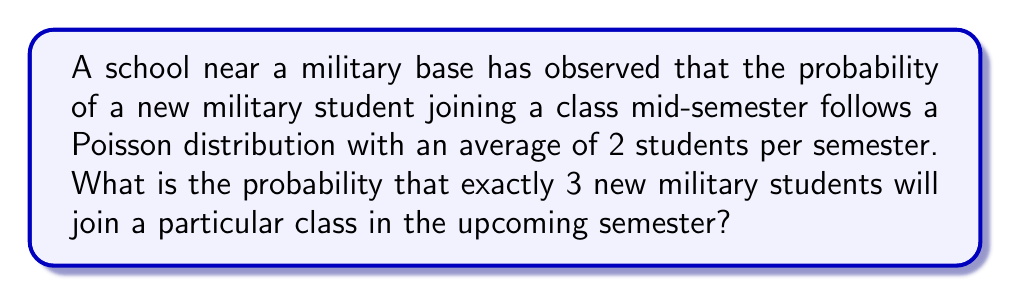What is the answer to this math problem? To solve this problem, we'll use the Poisson probability mass function:

$$P(X = k) = \frac{e^{-\lambda} \lambda^k}{k!}$$

Where:
$\lambda$ is the average rate of occurrence
$k$ is the number of occurrences we're interested in
$e$ is Euler's number (approximately 2.71828)

Given:
$\lambda = 2$ (average of 2 students per semester)
$k = 3$ (we want exactly 3 new students)

Step 1: Plug the values into the formula:
$$P(X = 3) = \frac{e^{-2} 2^3}{3!}$$

Step 2: Simplify the numerator:
$$P(X = 3) = \frac{e^{-2} \cdot 8}{3!}$$

Step 3: Calculate $3!$:
$$P(X = 3) = \frac{e^{-2} \cdot 8}{6}$$

Step 4: Simplify:
$$P(X = 3) = \frac{4e^{-2}}{3}$$

Step 5: Calculate the final value (rounded to 4 decimal places):
$$P(X = 3) \approx 0.1804$$

Therefore, the probability of exactly 3 new military students joining the class in the upcoming semester is approximately 0.1804 or 18.04%.
Answer: $0.1804$ 